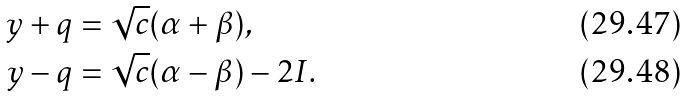<formula> <loc_0><loc_0><loc_500><loc_500>y + q & = \sqrt { c } ( \alpha + \beta ) , \\ y - q & = \sqrt { c } ( \alpha - \beta ) - 2 I .</formula> 